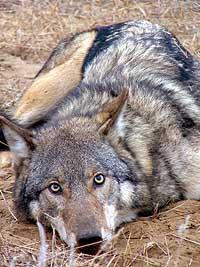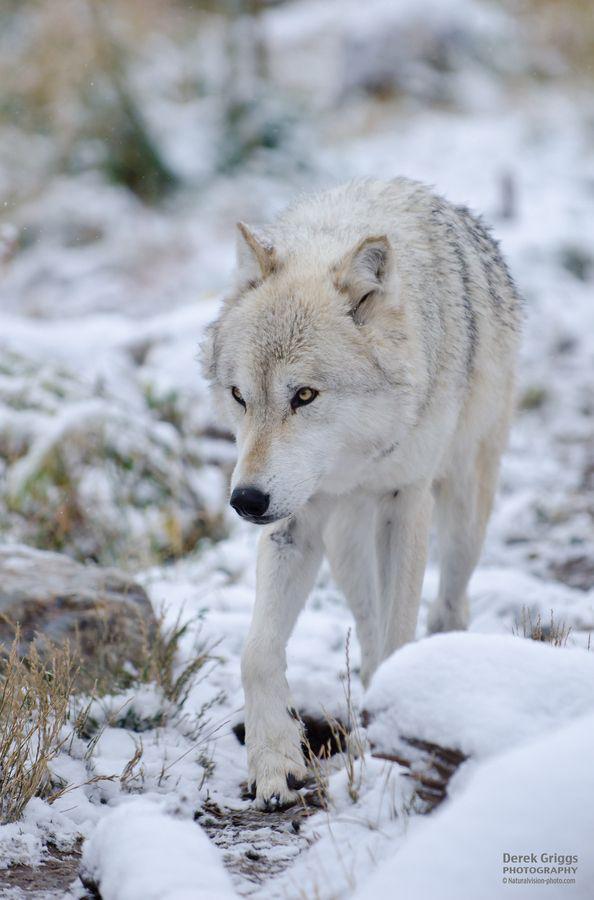The first image is the image on the left, the second image is the image on the right. For the images shown, is this caption "There is a wolf lying down with its head raised." true? Answer yes or no. No. 